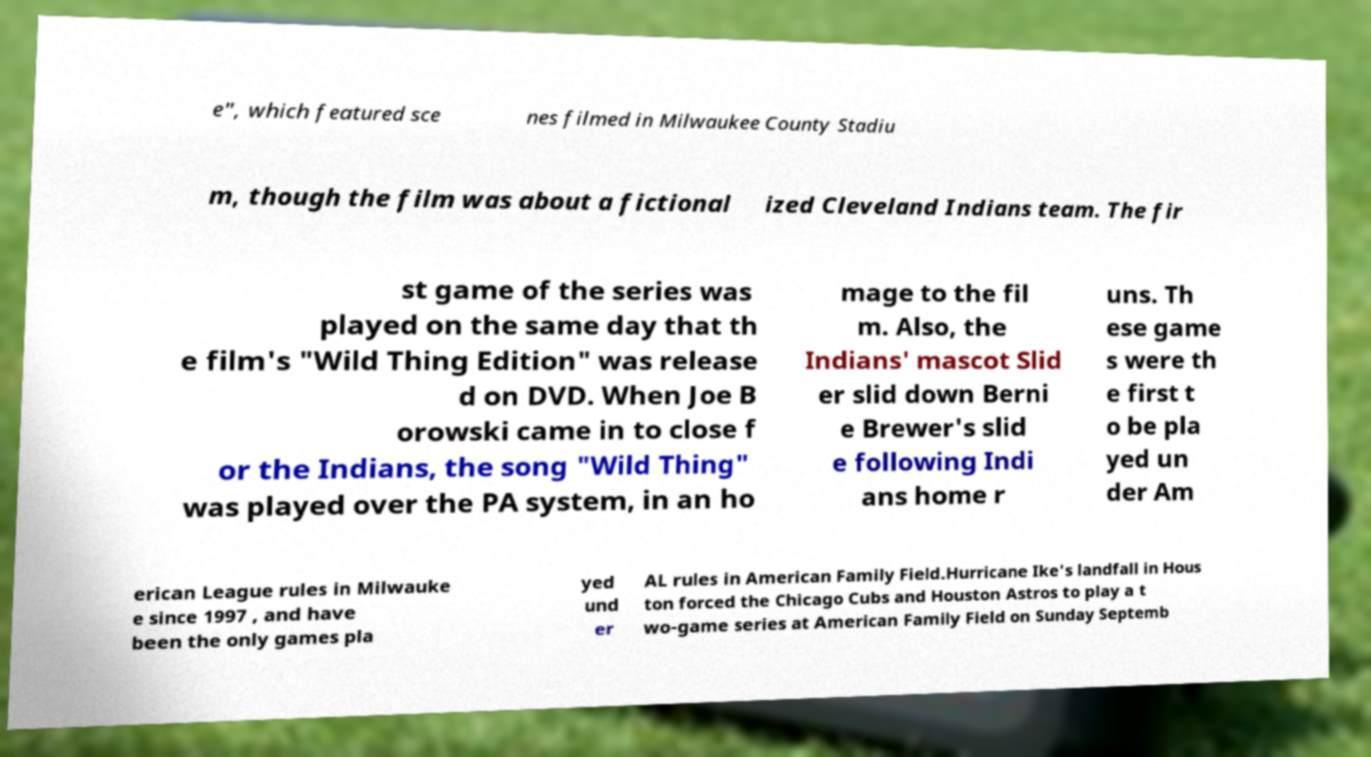I need the written content from this picture converted into text. Can you do that? e", which featured sce nes filmed in Milwaukee County Stadiu m, though the film was about a fictional ized Cleveland Indians team. The fir st game of the series was played on the same day that th e film's "Wild Thing Edition" was release d on DVD. When Joe B orowski came in to close f or the Indians, the song "Wild Thing" was played over the PA system, in an ho mage to the fil m. Also, the Indians' mascot Slid er slid down Berni e Brewer's slid e following Indi ans home r uns. Th ese game s were th e first t o be pla yed un der Am erican League rules in Milwauke e since 1997 , and have been the only games pla yed und er AL rules in American Family Field.Hurricane Ike's landfall in Hous ton forced the Chicago Cubs and Houston Astros to play a t wo-game series at American Family Field on Sunday Septemb 